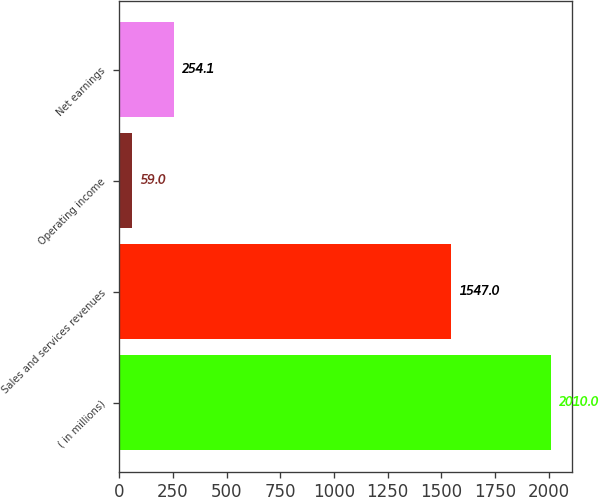Convert chart to OTSL. <chart><loc_0><loc_0><loc_500><loc_500><bar_chart><fcel>( in millions)<fcel>Sales and services revenues<fcel>Operating income<fcel>Net earnings<nl><fcel>2010<fcel>1547<fcel>59<fcel>254.1<nl></chart> 